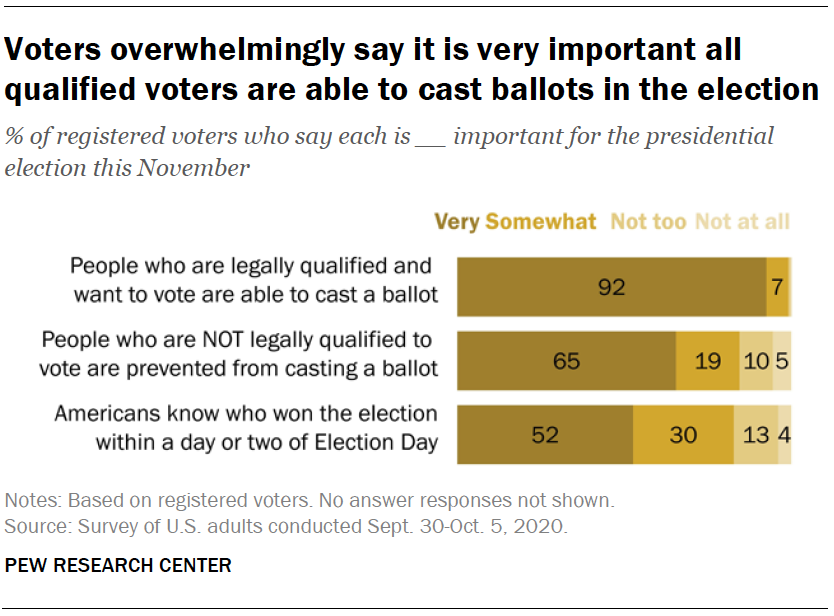Identify some key points in this picture. Find the missing data 65, _, 10, 5? 19 We would like to analyze the data and find the ratio between the bottom bar, the first two data points and the next two day values. 